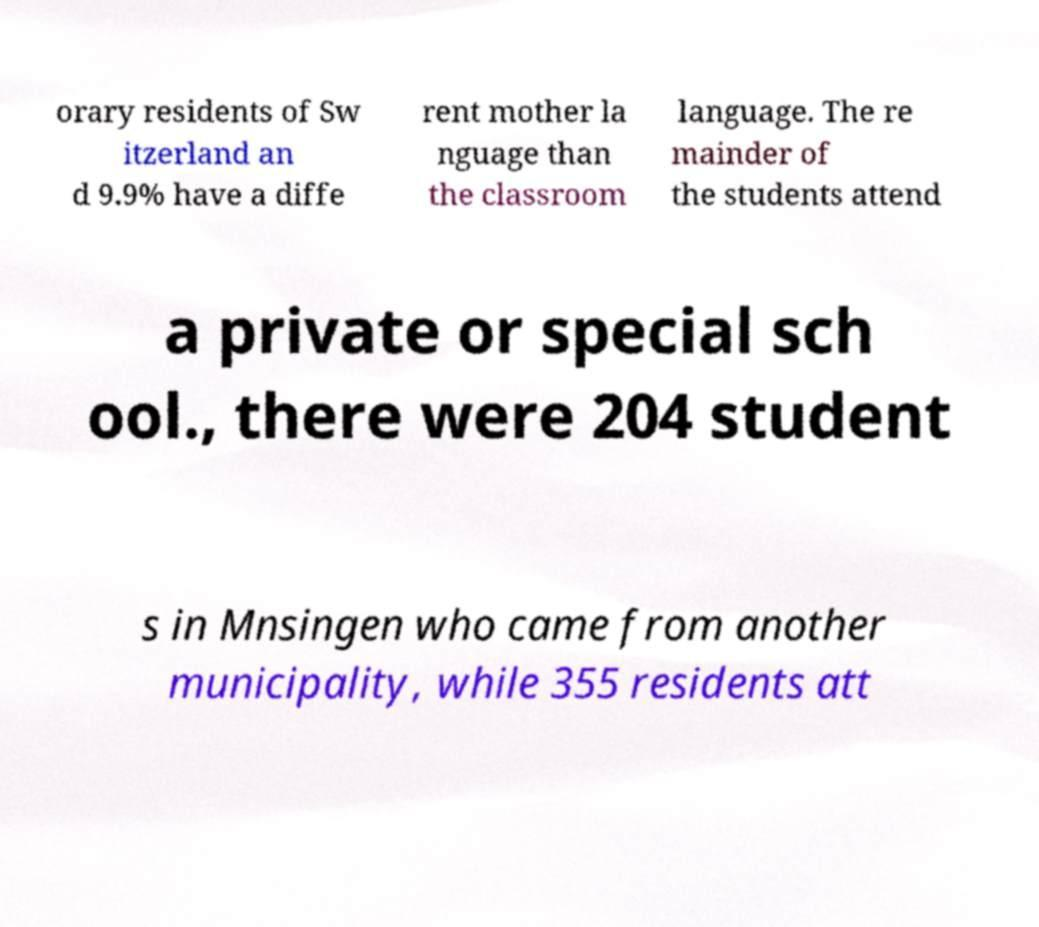Please identify and transcribe the text found in this image. orary residents of Sw itzerland an d 9.9% have a diffe rent mother la nguage than the classroom language. The re mainder of the students attend a private or special sch ool., there were 204 student s in Mnsingen who came from another municipality, while 355 residents att 